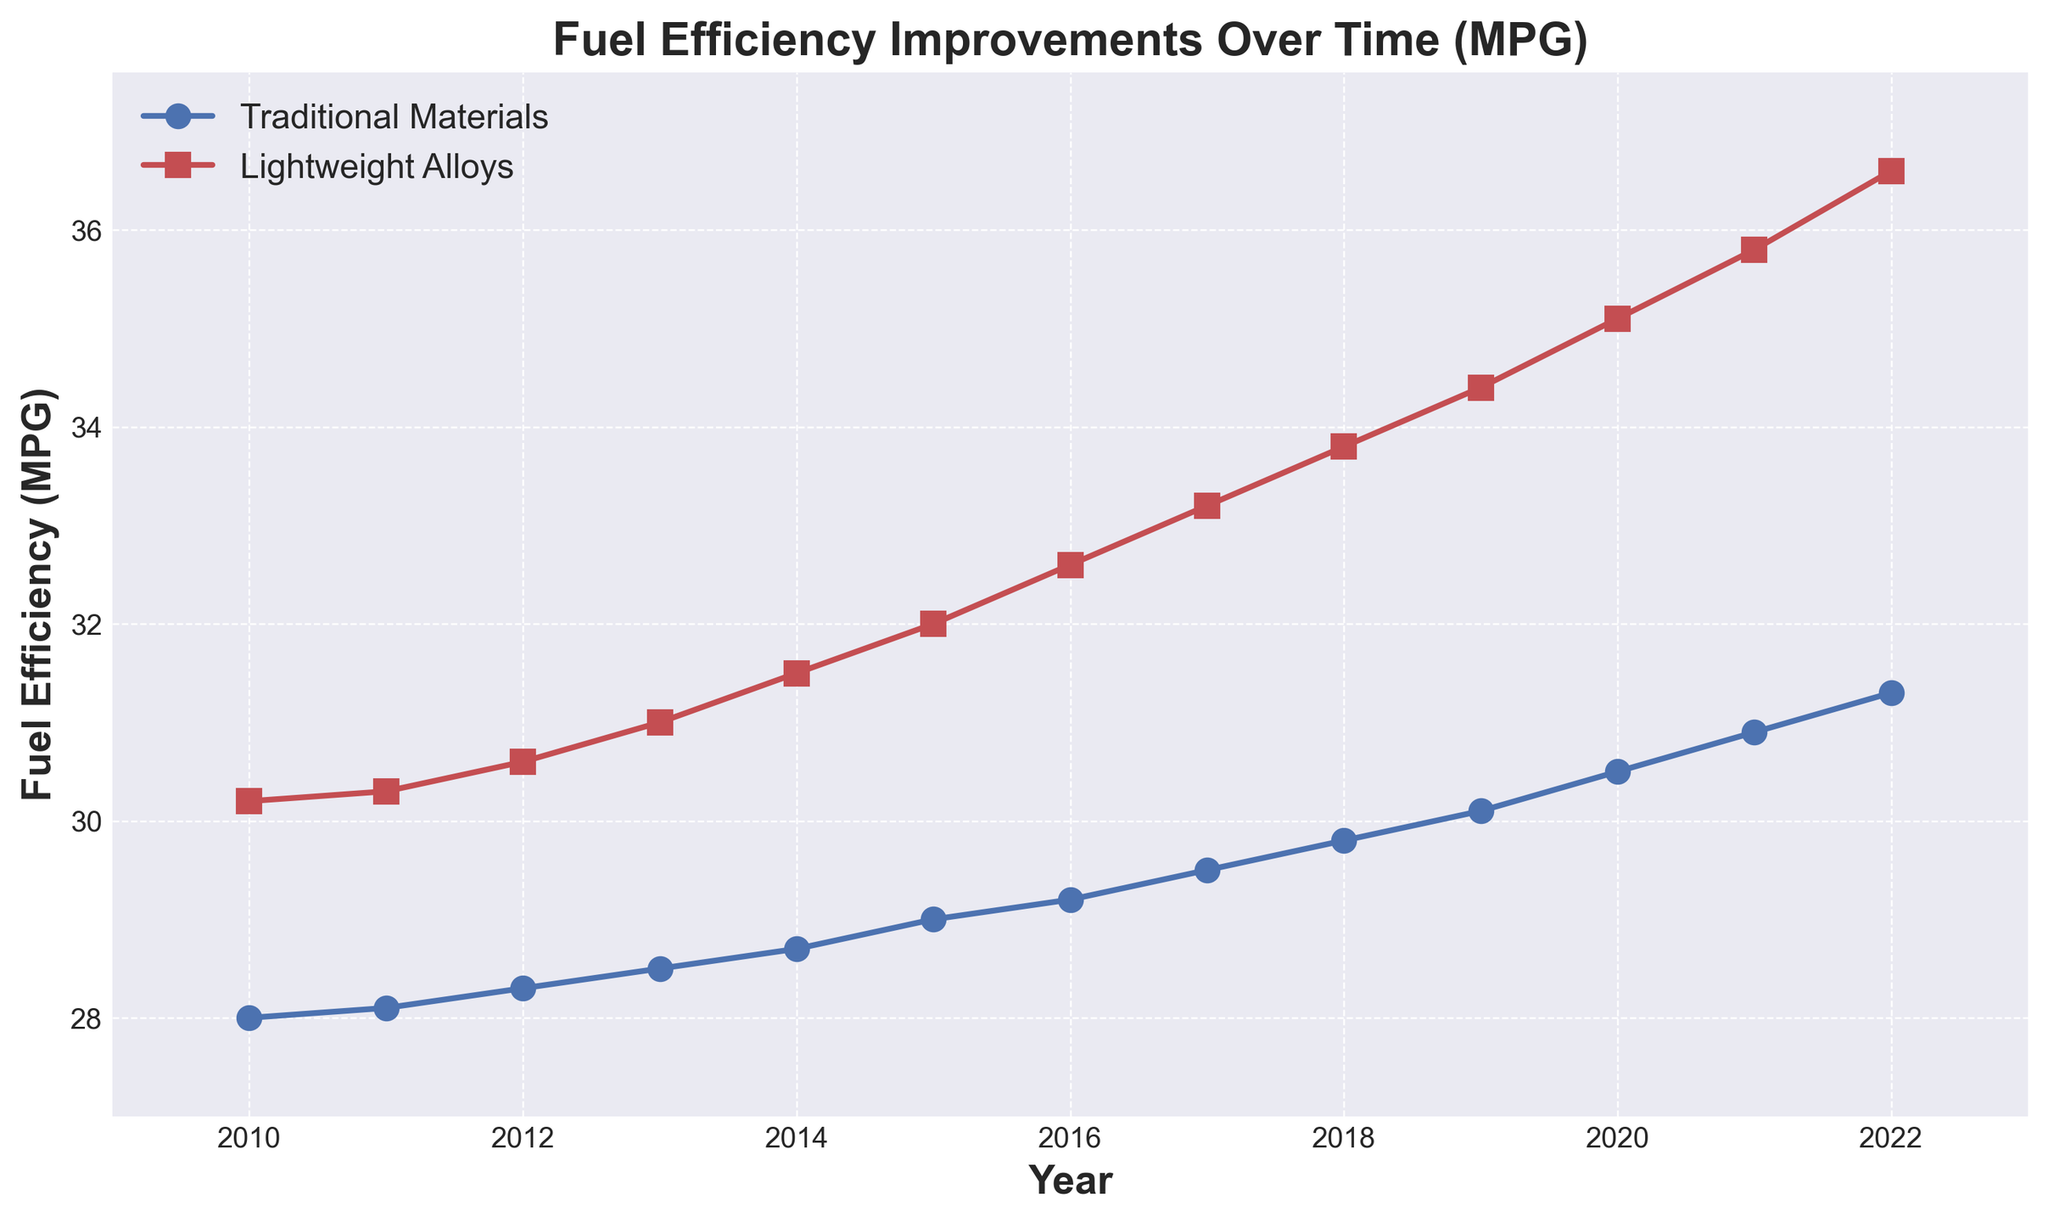What was the fuel efficiency for vehicles using traditional materials in 2015? Locate the point on the blue line corresponding to the year 2015, and read the MPG value.
Answer: 29.0 By how many MPG did the fuel efficiency of vehicles using lightweight alloys increase from 2010 to 2022? Determine the MPG for lightweight alloys in 2010 (30.2) and in 2022 (36.6). Then, calculate the difference: 36.6 - 30.2 = 6.4
Answer: 6.4 In which year did vehicles using lightweight alloys have a fuel efficiency of 32.6 MPG? Identify the point on the red line where the MPG is 32.6, and then find the corresponding year on the x-axis.
Answer: 2016 How much higher was the fuel efficiency of vehicles using lightweight alloys compared to traditional materials in 2020? Identify the MPG for lightweight alloys in 2020 (35.1) and for traditional materials in 2020 (30.5). Then, calculate the difference: 35.1 - 30.5 = 4.6
Answer: 4.6 What trend can be observed for the fuel efficiency of vehicles with traditional materials from 2010 to 2022? Observe the blue line from 2010 to 2022, which shows a consistent upward trend.
Answer: Increasing Which year had the smallest difference in MPG between traditional materials and lightweight alloys, and what was the difference? Calculate the differences for each year and identify the year with the smallest value. For example, in 2010 the difference is 30.2 - 28.0 = 2.2, and so on. The smallest difference is 1.7 in 2011.
Answer: 2011, 1.7 If the trend continues, what can be predicted about the fuel efficiency of vehicles using lightweight alloys in 2023? Extend the red line visually or analyze the trend of the red line, which shows an increase of approximately 0.7-0.9 MPG per year. Adding an average value (0.8) to 36.6 from 2022 results in 37.4 for 2023.
Answer: 37.4 What was the approximate average annual increase in fuel efficiency for vehicles using traditional materials from 2010 to 2022? Calculate the difference in MPG from 2010 to 2022 for traditional materials (31.3 - 28.0 = 3.3) and divide by the number of years (2022 - 2010 = 12). 3.3 / 12 ≈ 0.275
Answer: 0.275 Which material shows a steeper increase in fuel efficiency over the years, and how can this be visually identified? Compare the slopes of the blue and red lines. The red line (lightweight alloys) is steeper, indicating a faster increase in fuel efficiency.
Answer: Lightweight alloys 